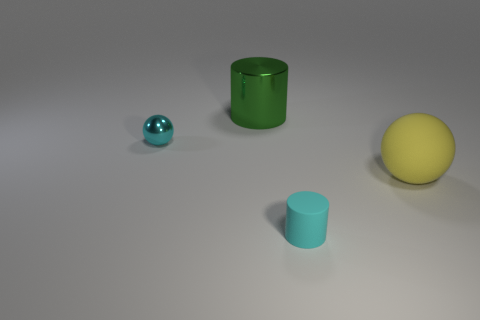What number of cylinders are big green rubber things or metallic objects?
Your answer should be very brief. 1. There is a tiny object that is to the left of the large green shiny cylinder; is there a tiny cyan thing that is on the left side of it?
Your answer should be very brief. No. Is there anything else that has the same material as the yellow ball?
Keep it short and to the point. Yes. Is the shape of the cyan metallic object the same as the large thing that is to the right of the tiny rubber cylinder?
Provide a succinct answer. Yes. What number of other things are there of the same size as the cyan shiny object?
Provide a short and direct response. 1. What number of cyan objects are either rubber cylinders or big balls?
Provide a succinct answer. 1. How many objects are behind the small rubber object and on the left side of the yellow rubber ball?
Provide a short and direct response. 2. What is the cylinder that is behind the tiny cyan thing that is on the right side of the big metal cylinder to the right of the metal sphere made of?
Keep it short and to the point. Metal. What number of balls have the same material as the big cylinder?
Ensure brevity in your answer.  1. There is a tiny thing that is the same color as the metallic sphere; what shape is it?
Your answer should be compact. Cylinder. 